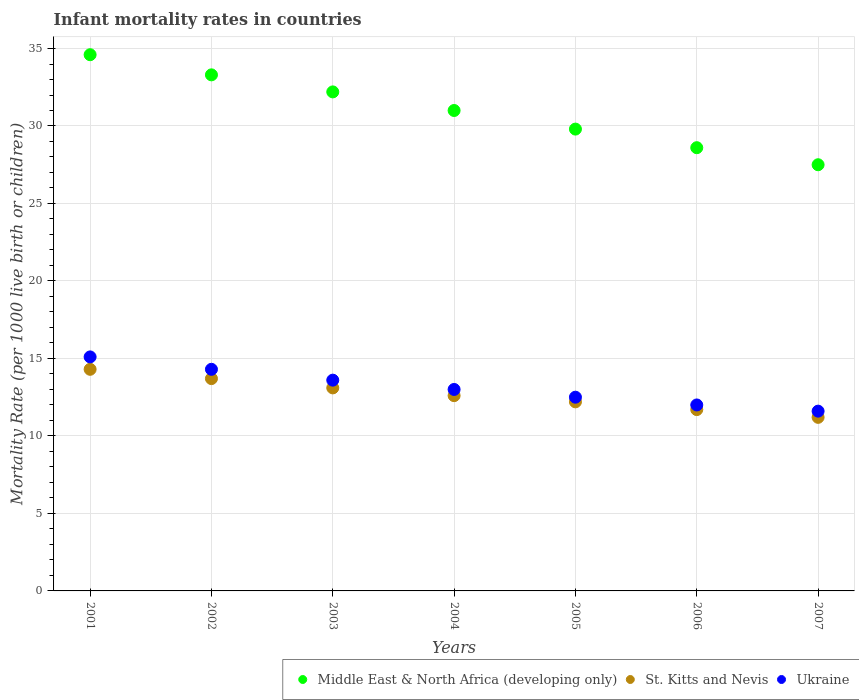Is the number of dotlines equal to the number of legend labels?
Give a very brief answer. Yes. Across all years, what is the maximum infant mortality rate in St. Kitts and Nevis?
Make the answer very short. 14.3. What is the total infant mortality rate in Middle East & North Africa (developing only) in the graph?
Offer a very short reply. 217. What is the difference between the infant mortality rate in St. Kitts and Nevis in 2004 and that in 2006?
Provide a short and direct response. 0.9. What is the difference between the infant mortality rate in St. Kitts and Nevis in 2002 and the infant mortality rate in Ukraine in 2003?
Offer a very short reply. 0.1. What is the average infant mortality rate in Ukraine per year?
Provide a short and direct response. 13.16. In the year 2001, what is the difference between the infant mortality rate in Ukraine and infant mortality rate in Middle East & North Africa (developing only)?
Make the answer very short. -19.5. What is the ratio of the infant mortality rate in Ukraine in 2001 to that in 2007?
Provide a succinct answer. 1.3. What is the difference between the highest and the second highest infant mortality rate in Middle East & North Africa (developing only)?
Your answer should be compact. 1.3. What is the difference between the highest and the lowest infant mortality rate in St. Kitts and Nevis?
Keep it short and to the point. 3.1. Is the sum of the infant mortality rate in Ukraine in 2005 and 2007 greater than the maximum infant mortality rate in Middle East & North Africa (developing only) across all years?
Keep it short and to the point. No. Is the infant mortality rate in Middle East & North Africa (developing only) strictly greater than the infant mortality rate in St. Kitts and Nevis over the years?
Offer a terse response. Yes. Is the infant mortality rate in Middle East & North Africa (developing only) strictly less than the infant mortality rate in Ukraine over the years?
Keep it short and to the point. No. How many dotlines are there?
Keep it short and to the point. 3. How many years are there in the graph?
Offer a very short reply. 7. How are the legend labels stacked?
Offer a very short reply. Horizontal. What is the title of the graph?
Your answer should be very brief. Infant mortality rates in countries. Does "Korea (Republic)" appear as one of the legend labels in the graph?
Offer a very short reply. No. What is the label or title of the X-axis?
Your answer should be very brief. Years. What is the label or title of the Y-axis?
Give a very brief answer. Mortality Rate (per 1000 live birth or children). What is the Mortality Rate (per 1000 live birth or children) of Middle East & North Africa (developing only) in 2001?
Offer a very short reply. 34.6. What is the Mortality Rate (per 1000 live birth or children) in Middle East & North Africa (developing only) in 2002?
Ensure brevity in your answer.  33.3. What is the Mortality Rate (per 1000 live birth or children) in St. Kitts and Nevis in 2002?
Your response must be concise. 13.7. What is the Mortality Rate (per 1000 live birth or children) in Middle East & North Africa (developing only) in 2003?
Offer a terse response. 32.2. What is the Mortality Rate (per 1000 live birth or children) of St. Kitts and Nevis in 2003?
Your answer should be compact. 13.1. What is the Mortality Rate (per 1000 live birth or children) in Ukraine in 2003?
Offer a very short reply. 13.6. What is the Mortality Rate (per 1000 live birth or children) of Middle East & North Africa (developing only) in 2005?
Give a very brief answer. 29.8. What is the Mortality Rate (per 1000 live birth or children) in St. Kitts and Nevis in 2005?
Give a very brief answer. 12.2. What is the Mortality Rate (per 1000 live birth or children) in Middle East & North Africa (developing only) in 2006?
Give a very brief answer. 28.6. What is the Mortality Rate (per 1000 live birth or children) in Middle East & North Africa (developing only) in 2007?
Your response must be concise. 27.5. What is the Mortality Rate (per 1000 live birth or children) in St. Kitts and Nevis in 2007?
Offer a terse response. 11.2. What is the Mortality Rate (per 1000 live birth or children) of Ukraine in 2007?
Ensure brevity in your answer.  11.6. Across all years, what is the maximum Mortality Rate (per 1000 live birth or children) of Middle East & North Africa (developing only)?
Make the answer very short. 34.6. Across all years, what is the maximum Mortality Rate (per 1000 live birth or children) of St. Kitts and Nevis?
Your response must be concise. 14.3. Across all years, what is the maximum Mortality Rate (per 1000 live birth or children) in Ukraine?
Give a very brief answer. 15.1. Across all years, what is the minimum Mortality Rate (per 1000 live birth or children) in Middle East & North Africa (developing only)?
Provide a succinct answer. 27.5. Across all years, what is the minimum Mortality Rate (per 1000 live birth or children) of St. Kitts and Nevis?
Offer a very short reply. 11.2. Across all years, what is the minimum Mortality Rate (per 1000 live birth or children) of Ukraine?
Ensure brevity in your answer.  11.6. What is the total Mortality Rate (per 1000 live birth or children) in Middle East & North Africa (developing only) in the graph?
Offer a very short reply. 217. What is the total Mortality Rate (per 1000 live birth or children) in St. Kitts and Nevis in the graph?
Offer a very short reply. 88.8. What is the total Mortality Rate (per 1000 live birth or children) of Ukraine in the graph?
Keep it short and to the point. 92.1. What is the difference between the Mortality Rate (per 1000 live birth or children) in Middle East & North Africa (developing only) in 2001 and that in 2003?
Your answer should be compact. 2.4. What is the difference between the Mortality Rate (per 1000 live birth or children) of St. Kitts and Nevis in 2001 and that in 2003?
Keep it short and to the point. 1.2. What is the difference between the Mortality Rate (per 1000 live birth or children) of St. Kitts and Nevis in 2001 and that in 2005?
Offer a terse response. 2.1. What is the difference between the Mortality Rate (per 1000 live birth or children) in Ukraine in 2001 and that in 2005?
Your answer should be compact. 2.6. What is the difference between the Mortality Rate (per 1000 live birth or children) in Middle East & North Africa (developing only) in 2001 and that in 2006?
Give a very brief answer. 6. What is the difference between the Mortality Rate (per 1000 live birth or children) in Ukraine in 2001 and that in 2006?
Make the answer very short. 3.1. What is the difference between the Mortality Rate (per 1000 live birth or children) of St. Kitts and Nevis in 2001 and that in 2007?
Offer a terse response. 3.1. What is the difference between the Mortality Rate (per 1000 live birth or children) of Middle East & North Africa (developing only) in 2002 and that in 2003?
Your response must be concise. 1.1. What is the difference between the Mortality Rate (per 1000 live birth or children) of St. Kitts and Nevis in 2002 and that in 2004?
Your response must be concise. 1.1. What is the difference between the Mortality Rate (per 1000 live birth or children) of Ukraine in 2002 and that in 2004?
Offer a very short reply. 1.3. What is the difference between the Mortality Rate (per 1000 live birth or children) of St. Kitts and Nevis in 2002 and that in 2005?
Provide a short and direct response. 1.5. What is the difference between the Mortality Rate (per 1000 live birth or children) of Ukraine in 2002 and that in 2005?
Your answer should be very brief. 1.8. What is the difference between the Mortality Rate (per 1000 live birth or children) of St. Kitts and Nevis in 2002 and that in 2006?
Ensure brevity in your answer.  2. What is the difference between the Mortality Rate (per 1000 live birth or children) of Ukraine in 2002 and that in 2007?
Make the answer very short. 2.7. What is the difference between the Mortality Rate (per 1000 live birth or children) of Middle East & North Africa (developing only) in 2003 and that in 2004?
Give a very brief answer. 1.2. What is the difference between the Mortality Rate (per 1000 live birth or children) of St. Kitts and Nevis in 2003 and that in 2004?
Offer a terse response. 0.5. What is the difference between the Mortality Rate (per 1000 live birth or children) in Middle East & North Africa (developing only) in 2003 and that in 2006?
Give a very brief answer. 3.6. What is the difference between the Mortality Rate (per 1000 live birth or children) in St. Kitts and Nevis in 2003 and that in 2006?
Your answer should be compact. 1.4. What is the difference between the Mortality Rate (per 1000 live birth or children) of Middle East & North Africa (developing only) in 2003 and that in 2007?
Provide a succinct answer. 4.7. What is the difference between the Mortality Rate (per 1000 live birth or children) of St. Kitts and Nevis in 2003 and that in 2007?
Your answer should be compact. 1.9. What is the difference between the Mortality Rate (per 1000 live birth or children) in Middle East & North Africa (developing only) in 2004 and that in 2006?
Keep it short and to the point. 2.4. What is the difference between the Mortality Rate (per 1000 live birth or children) in Ukraine in 2004 and that in 2006?
Offer a very short reply. 1. What is the difference between the Mortality Rate (per 1000 live birth or children) in Middle East & North Africa (developing only) in 2004 and that in 2007?
Offer a terse response. 3.5. What is the difference between the Mortality Rate (per 1000 live birth or children) of Ukraine in 2004 and that in 2007?
Provide a short and direct response. 1.4. What is the difference between the Mortality Rate (per 1000 live birth or children) of Middle East & North Africa (developing only) in 2005 and that in 2006?
Give a very brief answer. 1.2. What is the difference between the Mortality Rate (per 1000 live birth or children) of St. Kitts and Nevis in 2005 and that in 2006?
Offer a terse response. 0.5. What is the difference between the Mortality Rate (per 1000 live birth or children) in Ukraine in 2005 and that in 2006?
Offer a terse response. 0.5. What is the difference between the Mortality Rate (per 1000 live birth or children) of Middle East & North Africa (developing only) in 2005 and that in 2007?
Offer a very short reply. 2.3. What is the difference between the Mortality Rate (per 1000 live birth or children) in Ukraine in 2006 and that in 2007?
Your answer should be compact. 0.4. What is the difference between the Mortality Rate (per 1000 live birth or children) in Middle East & North Africa (developing only) in 2001 and the Mortality Rate (per 1000 live birth or children) in St. Kitts and Nevis in 2002?
Give a very brief answer. 20.9. What is the difference between the Mortality Rate (per 1000 live birth or children) of Middle East & North Africa (developing only) in 2001 and the Mortality Rate (per 1000 live birth or children) of Ukraine in 2002?
Ensure brevity in your answer.  20.3. What is the difference between the Mortality Rate (per 1000 live birth or children) in St. Kitts and Nevis in 2001 and the Mortality Rate (per 1000 live birth or children) in Ukraine in 2002?
Offer a very short reply. 0. What is the difference between the Mortality Rate (per 1000 live birth or children) of Middle East & North Africa (developing only) in 2001 and the Mortality Rate (per 1000 live birth or children) of Ukraine in 2003?
Provide a short and direct response. 21. What is the difference between the Mortality Rate (per 1000 live birth or children) in Middle East & North Africa (developing only) in 2001 and the Mortality Rate (per 1000 live birth or children) in St. Kitts and Nevis in 2004?
Give a very brief answer. 22. What is the difference between the Mortality Rate (per 1000 live birth or children) in Middle East & North Africa (developing only) in 2001 and the Mortality Rate (per 1000 live birth or children) in Ukraine in 2004?
Your response must be concise. 21.6. What is the difference between the Mortality Rate (per 1000 live birth or children) of St. Kitts and Nevis in 2001 and the Mortality Rate (per 1000 live birth or children) of Ukraine in 2004?
Provide a succinct answer. 1.3. What is the difference between the Mortality Rate (per 1000 live birth or children) of Middle East & North Africa (developing only) in 2001 and the Mortality Rate (per 1000 live birth or children) of St. Kitts and Nevis in 2005?
Give a very brief answer. 22.4. What is the difference between the Mortality Rate (per 1000 live birth or children) in Middle East & North Africa (developing only) in 2001 and the Mortality Rate (per 1000 live birth or children) in Ukraine in 2005?
Offer a very short reply. 22.1. What is the difference between the Mortality Rate (per 1000 live birth or children) of St. Kitts and Nevis in 2001 and the Mortality Rate (per 1000 live birth or children) of Ukraine in 2005?
Ensure brevity in your answer.  1.8. What is the difference between the Mortality Rate (per 1000 live birth or children) of Middle East & North Africa (developing only) in 2001 and the Mortality Rate (per 1000 live birth or children) of St. Kitts and Nevis in 2006?
Provide a succinct answer. 22.9. What is the difference between the Mortality Rate (per 1000 live birth or children) in Middle East & North Africa (developing only) in 2001 and the Mortality Rate (per 1000 live birth or children) in Ukraine in 2006?
Your answer should be very brief. 22.6. What is the difference between the Mortality Rate (per 1000 live birth or children) in St. Kitts and Nevis in 2001 and the Mortality Rate (per 1000 live birth or children) in Ukraine in 2006?
Ensure brevity in your answer.  2.3. What is the difference between the Mortality Rate (per 1000 live birth or children) of Middle East & North Africa (developing only) in 2001 and the Mortality Rate (per 1000 live birth or children) of St. Kitts and Nevis in 2007?
Your answer should be very brief. 23.4. What is the difference between the Mortality Rate (per 1000 live birth or children) of St. Kitts and Nevis in 2001 and the Mortality Rate (per 1000 live birth or children) of Ukraine in 2007?
Offer a terse response. 2.7. What is the difference between the Mortality Rate (per 1000 live birth or children) of Middle East & North Africa (developing only) in 2002 and the Mortality Rate (per 1000 live birth or children) of St. Kitts and Nevis in 2003?
Offer a very short reply. 20.2. What is the difference between the Mortality Rate (per 1000 live birth or children) in Middle East & North Africa (developing only) in 2002 and the Mortality Rate (per 1000 live birth or children) in Ukraine in 2003?
Your answer should be compact. 19.7. What is the difference between the Mortality Rate (per 1000 live birth or children) in St. Kitts and Nevis in 2002 and the Mortality Rate (per 1000 live birth or children) in Ukraine in 2003?
Provide a succinct answer. 0.1. What is the difference between the Mortality Rate (per 1000 live birth or children) of Middle East & North Africa (developing only) in 2002 and the Mortality Rate (per 1000 live birth or children) of St. Kitts and Nevis in 2004?
Your response must be concise. 20.7. What is the difference between the Mortality Rate (per 1000 live birth or children) in Middle East & North Africa (developing only) in 2002 and the Mortality Rate (per 1000 live birth or children) in Ukraine in 2004?
Provide a succinct answer. 20.3. What is the difference between the Mortality Rate (per 1000 live birth or children) of Middle East & North Africa (developing only) in 2002 and the Mortality Rate (per 1000 live birth or children) of St. Kitts and Nevis in 2005?
Offer a terse response. 21.1. What is the difference between the Mortality Rate (per 1000 live birth or children) of Middle East & North Africa (developing only) in 2002 and the Mortality Rate (per 1000 live birth or children) of Ukraine in 2005?
Offer a very short reply. 20.8. What is the difference between the Mortality Rate (per 1000 live birth or children) in Middle East & North Africa (developing only) in 2002 and the Mortality Rate (per 1000 live birth or children) in St. Kitts and Nevis in 2006?
Provide a succinct answer. 21.6. What is the difference between the Mortality Rate (per 1000 live birth or children) in Middle East & North Africa (developing only) in 2002 and the Mortality Rate (per 1000 live birth or children) in Ukraine in 2006?
Offer a very short reply. 21.3. What is the difference between the Mortality Rate (per 1000 live birth or children) in Middle East & North Africa (developing only) in 2002 and the Mortality Rate (per 1000 live birth or children) in St. Kitts and Nevis in 2007?
Give a very brief answer. 22.1. What is the difference between the Mortality Rate (per 1000 live birth or children) of Middle East & North Africa (developing only) in 2002 and the Mortality Rate (per 1000 live birth or children) of Ukraine in 2007?
Provide a succinct answer. 21.7. What is the difference between the Mortality Rate (per 1000 live birth or children) of St. Kitts and Nevis in 2002 and the Mortality Rate (per 1000 live birth or children) of Ukraine in 2007?
Ensure brevity in your answer.  2.1. What is the difference between the Mortality Rate (per 1000 live birth or children) in Middle East & North Africa (developing only) in 2003 and the Mortality Rate (per 1000 live birth or children) in St. Kitts and Nevis in 2004?
Offer a very short reply. 19.6. What is the difference between the Mortality Rate (per 1000 live birth or children) of Middle East & North Africa (developing only) in 2003 and the Mortality Rate (per 1000 live birth or children) of Ukraine in 2004?
Your response must be concise. 19.2. What is the difference between the Mortality Rate (per 1000 live birth or children) of Middle East & North Africa (developing only) in 2003 and the Mortality Rate (per 1000 live birth or children) of St. Kitts and Nevis in 2005?
Provide a short and direct response. 20. What is the difference between the Mortality Rate (per 1000 live birth or children) of Middle East & North Africa (developing only) in 2003 and the Mortality Rate (per 1000 live birth or children) of Ukraine in 2005?
Ensure brevity in your answer.  19.7. What is the difference between the Mortality Rate (per 1000 live birth or children) of St. Kitts and Nevis in 2003 and the Mortality Rate (per 1000 live birth or children) of Ukraine in 2005?
Make the answer very short. 0.6. What is the difference between the Mortality Rate (per 1000 live birth or children) of Middle East & North Africa (developing only) in 2003 and the Mortality Rate (per 1000 live birth or children) of St. Kitts and Nevis in 2006?
Provide a succinct answer. 20.5. What is the difference between the Mortality Rate (per 1000 live birth or children) of Middle East & North Africa (developing only) in 2003 and the Mortality Rate (per 1000 live birth or children) of Ukraine in 2006?
Ensure brevity in your answer.  20.2. What is the difference between the Mortality Rate (per 1000 live birth or children) of Middle East & North Africa (developing only) in 2003 and the Mortality Rate (per 1000 live birth or children) of Ukraine in 2007?
Offer a very short reply. 20.6. What is the difference between the Mortality Rate (per 1000 live birth or children) of St. Kitts and Nevis in 2003 and the Mortality Rate (per 1000 live birth or children) of Ukraine in 2007?
Your answer should be very brief. 1.5. What is the difference between the Mortality Rate (per 1000 live birth or children) in Middle East & North Africa (developing only) in 2004 and the Mortality Rate (per 1000 live birth or children) in St. Kitts and Nevis in 2005?
Keep it short and to the point. 18.8. What is the difference between the Mortality Rate (per 1000 live birth or children) in Middle East & North Africa (developing only) in 2004 and the Mortality Rate (per 1000 live birth or children) in St. Kitts and Nevis in 2006?
Your answer should be compact. 19.3. What is the difference between the Mortality Rate (per 1000 live birth or children) in Middle East & North Africa (developing only) in 2004 and the Mortality Rate (per 1000 live birth or children) in St. Kitts and Nevis in 2007?
Make the answer very short. 19.8. What is the difference between the Mortality Rate (per 1000 live birth or children) in St. Kitts and Nevis in 2004 and the Mortality Rate (per 1000 live birth or children) in Ukraine in 2007?
Your answer should be compact. 1. What is the difference between the Mortality Rate (per 1000 live birth or children) of St. Kitts and Nevis in 2005 and the Mortality Rate (per 1000 live birth or children) of Ukraine in 2006?
Give a very brief answer. 0.2. What is the difference between the Mortality Rate (per 1000 live birth or children) in Middle East & North Africa (developing only) in 2005 and the Mortality Rate (per 1000 live birth or children) in Ukraine in 2007?
Your answer should be compact. 18.2. What is the difference between the Mortality Rate (per 1000 live birth or children) in Middle East & North Africa (developing only) in 2006 and the Mortality Rate (per 1000 live birth or children) in St. Kitts and Nevis in 2007?
Make the answer very short. 17.4. What is the difference between the Mortality Rate (per 1000 live birth or children) in Middle East & North Africa (developing only) in 2006 and the Mortality Rate (per 1000 live birth or children) in Ukraine in 2007?
Keep it short and to the point. 17. What is the difference between the Mortality Rate (per 1000 live birth or children) of St. Kitts and Nevis in 2006 and the Mortality Rate (per 1000 live birth or children) of Ukraine in 2007?
Provide a succinct answer. 0.1. What is the average Mortality Rate (per 1000 live birth or children) of Middle East & North Africa (developing only) per year?
Provide a short and direct response. 31. What is the average Mortality Rate (per 1000 live birth or children) of St. Kitts and Nevis per year?
Offer a very short reply. 12.69. What is the average Mortality Rate (per 1000 live birth or children) of Ukraine per year?
Keep it short and to the point. 13.16. In the year 2001, what is the difference between the Mortality Rate (per 1000 live birth or children) of Middle East & North Africa (developing only) and Mortality Rate (per 1000 live birth or children) of St. Kitts and Nevis?
Your response must be concise. 20.3. In the year 2001, what is the difference between the Mortality Rate (per 1000 live birth or children) in Middle East & North Africa (developing only) and Mortality Rate (per 1000 live birth or children) in Ukraine?
Provide a short and direct response. 19.5. In the year 2001, what is the difference between the Mortality Rate (per 1000 live birth or children) of St. Kitts and Nevis and Mortality Rate (per 1000 live birth or children) of Ukraine?
Make the answer very short. -0.8. In the year 2002, what is the difference between the Mortality Rate (per 1000 live birth or children) in Middle East & North Africa (developing only) and Mortality Rate (per 1000 live birth or children) in St. Kitts and Nevis?
Offer a very short reply. 19.6. In the year 2003, what is the difference between the Mortality Rate (per 1000 live birth or children) of Middle East & North Africa (developing only) and Mortality Rate (per 1000 live birth or children) of St. Kitts and Nevis?
Your answer should be very brief. 19.1. In the year 2004, what is the difference between the Mortality Rate (per 1000 live birth or children) in Middle East & North Africa (developing only) and Mortality Rate (per 1000 live birth or children) in St. Kitts and Nevis?
Your answer should be compact. 18.4. In the year 2005, what is the difference between the Mortality Rate (per 1000 live birth or children) of Middle East & North Africa (developing only) and Mortality Rate (per 1000 live birth or children) of St. Kitts and Nevis?
Ensure brevity in your answer.  17.6. In the year 2006, what is the difference between the Mortality Rate (per 1000 live birth or children) of St. Kitts and Nevis and Mortality Rate (per 1000 live birth or children) of Ukraine?
Provide a short and direct response. -0.3. In the year 2007, what is the difference between the Mortality Rate (per 1000 live birth or children) in St. Kitts and Nevis and Mortality Rate (per 1000 live birth or children) in Ukraine?
Your answer should be compact. -0.4. What is the ratio of the Mortality Rate (per 1000 live birth or children) in Middle East & North Africa (developing only) in 2001 to that in 2002?
Provide a succinct answer. 1.04. What is the ratio of the Mortality Rate (per 1000 live birth or children) in St. Kitts and Nevis in 2001 to that in 2002?
Your answer should be compact. 1.04. What is the ratio of the Mortality Rate (per 1000 live birth or children) in Ukraine in 2001 to that in 2002?
Provide a short and direct response. 1.06. What is the ratio of the Mortality Rate (per 1000 live birth or children) of Middle East & North Africa (developing only) in 2001 to that in 2003?
Your answer should be compact. 1.07. What is the ratio of the Mortality Rate (per 1000 live birth or children) in St. Kitts and Nevis in 2001 to that in 2003?
Your answer should be very brief. 1.09. What is the ratio of the Mortality Rate (per 1000 live birth or children) in Ukraine in 2001 to that in 2003?
Your answer should be very brief. 1.11. What is the ratio of the Mortality Rate (per 1000 live birth or children) of Middle East & North Africa (developing only) in 2001 to that in 2004?
Ensure brevity in your answer.  1.12. What is the ratio of the Mortality Rate (per 1000 live birth or children) in St. Kitts and Nevis in 2001 to that in 2004?
Give a very brief answer. 1.13. What is the ratio of the Mortality Rate (per 1000 live birth or children) in Ukraine in 2001 to that in 2004?
Ensure brevity in your answer.  1.16. What is the ratio of the Mortality Rate (per 1000 live birth or children) in Middle East & North Africa (developing only) in 2001 to that in 2005?
Your answer should be very brief. 1.16. What is the ratio of the Mortality Rate (per 1000 live birth or children) of St. Kitts and Nevis in 2001 to that in 2005?
Your answer should be compact. 1.17. What is the ratio of the Mortality Rate (per 1000 live birth or children) of Ukraine in 2001 to that in 2005?
Make the answer very short. 1.21. What is the ratio of the Mortality Rate (per 1000 live birth or children) in Middle East & North Africa (developing only) in 2001 to that in 2006?
Your answer should be very brief. 1.21. What is the ratio of the Mortality Rate (per 1000 live birth or children) of St. Kitts and Nevis in 2001 to that in 2006?
Your response must be concise. 1.22. What is the ratio of the Mortality Rate (per 1000 live birth or children) of Ukraine in 2001 to that in 2006?
Offer a terse response. 1.26. What is the ratio of the Mortality Rate (per 1000 live birth or children) in Middle East & North Africa (developing only) in 2001 to that in 2007?
Ensure brevity in your answer.  1.26. What is the ratio of the Mortality Rate (per 1000 live birth or children) of St. Kitts and Nevis in 2001 to that in 2007?
Give a very brief answer. 1.28. What is the ratio of the Mortality Rate (per 1000 live birth or children) of Ukraine in 2001 to that in 2007?
Your response must be concise. 1.3. What is the ratio of the Mortality Rate (per 1000 live birth or children) in Middle East & North Africa (developing only) in 2002 to that in 2003?
Your answer should be very brief. 1.03. What is the ratio of the Mortality Rate (per 1000 live birth or children) of St. Kitts and Nevis in 2002 to that in 2003?
Provide a succinct answer. 1.05. What is the ratio of the Mortality Rate (per 1000 live birth or children) of Ukraine in 2002 to that in 2003?
Offer a terse response. 1.05. What is the ratio of the Mortality Rate (per 1000 live birth or children) of Middle East & North Africa (developing only) in 2002 to that in 2004?
Your answer should be very brief. 1.07. What is the ratio of the Mortality Rate (per 1000 live birth or children) of St. Kitts and Nevis in 2002 to that in 2004?
Give a very brief answer. 1.09. What is the ratio of the Mortality Rate (per 1000 live birth or children) in Ukraine in 2002 to that in 2004?
Provide a short and direct response. 1.1. What is the ratio of the Mortality Rate (per 1000 live birth or children) of Middle East & North Africa (developing only) in 2002 to that in 2005?
Your response must be concise. 1.12. What is the ratio of the Mortality Rate (per 1000 live birth or children) in St. Kitts and Nevis in 2002 to that in 2005?
Your response must be concise. 1.12. What is the ratio of the Mortality Rate (per 1000 live birth or children) in Ukraine in 2002 to that in 2005?
Make the answer very short. 1.14. What is the ratio of the Mortality Rate (per 1000 live birth or children) in Middle East & North Africa (developing only) in 2002 to that in 2006?
Keep it short and to the point. 1.16. What is the ratio of the Mortality Rate (per 1000 live birth or children) of St. Kitts and Nevis in 2002 to that in 2006?
Offer a terse response. 1.17. What is the ratio of the Mortality Rate (per 1000 live birth or children) in Ukraine in 2002 to that in 2006?
Offer a very short reply. 1.19. What is the ratio of the Mortality Rate (per 1000 live birth or children) of Middle East & North Africa (developing only) in 2002 to that in 2007?
Your answer should be very brief. 1.21. What is the ratio of the Mortality Rate (per 1000 live birth or children) of St. Kitts and Nevis in 2002 to that in 2007?
Offer a very short reply. 1.22. What is the ratio of the Mortality Rate (per 1000 live birth or children) in Ukraine in 2002 to that in 2007?
Offer a very short reply. 1.23. What is the ratio of the Mortality Rate (per 1000 live birth or children) of Middle East & North Africa (developing only) in 2003 to that in 2004?
Your answer should be very brief. 1.04. What is the ratio of the Mortality Rate (per 1000 live birth or children) in St. Kitts and Nevis in 2003 to that in 2004?
Provide a succinct answer. 1.04. What is the ratio of the Mortality Rate (per 1000 live birth or children) in Ukraine in 2003 to that in 2004?
Give a very brief answer. 1.05. What is the ratio of the Mortality Rate (per 1000 live birth or children) in Middle East & North Africa (developing only) in 2003 to that in 2005?
Offer a terse response. 1.08. What is the ratio of the Mortality Rate (per 1000 live birth or children) of St. Kitts and Nevis in 2003 to that in 2005?
Give a very brief answer. 1.07. What is the ratio of the Mortality Rate (per 1000 live birth or children) of Ukraine in 2003 to that in 2005?
Ensure brevity in your answer.  1.09. What is the ratio of the Mortality Rate (per 1000 live birth or children) in Middle East & North Africa (developing only) in 2003 to that in 2006?
Your response must be concise. 1.13. What is the ratio of the Mortality Rate (per 1000 live birth or children) of St. Kitts and Nevis in 2003 to that in 2006?
Ensure brevity in your answer.  1.12. What is the ratio of the Mortality Rate (per 1000 live birth or children) of Ukraine in 2003 to that in 2006?
Make the answer very short. 1.13. What is the ratio of the Mortality Rate (per 1000 live birth or children) of Middle East & North Africa (developing only) in 2003 to that in 2007?
Provide a succinct answer. 1.17. What is the ratio of the Mortality Rate (per 1000 live birth or children) in St. Kitts and Nevis in 2003 to that in 2007?
Offer a terse response. 1.17. What is the ratio of the Mortality Rate (per 1000 live birth or children) in Ukraine in 2003 to that in 2007?
Keep it short and to the point. 1.17. What is the ratio of the Mortality Rate (per 1000 live birth or children) in Middle East & North Africa (developing only) in 2004 to that in 2005?
Give a very brief answer. 1.04. What is the ratio of the Mortality Rate (per 1000 live birth or children) in St. Kitts and Nevis in 2004 to that in 2005?
Ensure brevity in your answer.  1.03. What is the ratio of the Mortality Rate (per 1000 live birth or children) in Ukraine in 2004 to that in 2005?
Make the answer very short. 1.04. What is the ratio of the Mortality Rate (per 1000 live birth or children) in Middle East & North Africa (developing only) in 2004 to that in 2006?
Offer a terse response. 1.08. What is the ratio of the Mortality Rate (per 1000 live birth or children) of St. Kitts and Nevis in 2004 to that in 2006?
Give a very brief answer. 1.08. What is the ratio of the Mortality Rate (per 1000 live birth or children) in Ukraine in 2004 to that in 2006?
Keep it short and to the point. 1.08. What is the ratio of the Mortality Rate (per 1000 live birth or children) of Middle East & North Africa (developing only) in 2004 to that in 2007?
Give a very brief answer. 1.13. What is the ratio of the Mortality Rate (per 1000 live birth or children) of St. Kitts and Nevis in 2004 to that in 2007?
Your answer should be compact. 1.12. What is the ratio of the Mortality Rate (per 1000 live birth or children) in Ukraine in 2004 to that in 2007?
Ensure brevity in your answer.  1.12. What is the ratio of the Mortality Rate (per 1000 live birth or children) in Middle East & North Africa (developing only) in 2005 to that in 2006?
Your response must be concise. 1.04. What is the ratio of the Mortality Rate (per 1000 live birth or children) in St. Kitts and Nevis in 2005 to that in 2006?
Your response must be concise. 1.04. What is the ratio of the Mortality Rate (per 1000 live birth or children) of Ukraine in 2005 to that in 2006?
Provide a short and direct response. 1.04. What is the ratio of the Mortality Rate (per 1000 live birth or children) of Middle East & North Africa (developing only) in 2005 to that in 2007?
Give a very brief answer. 1.08. What is the ratio of the Mortality Rate (per 1000 live birth or children) in St. Kitts and Nevis in 2005 to that in 2007?
Offer a very short reply. 1.09. What is the ratio of the Mortality Rate (per 1000 live birth or children) in Ukraine in 2005 to that in 2007?
Your response must be concise. 1.08. What is the ratio of the Mortality Rate (per 1000 live birth or children) of St. Kitts and Nevis in 2006 to that in 2007?
Provide a short and direct response. 1.04. What is the ratio of the Mortality Rate (per 1000 live birth or children) of Ukraine in 2006 to that in 2007?
Make the answer very short. 1.03. What is the difference between the highest and the second highest Mortality Rate (per 1000 live birth or children) in St. Kitts and Nevis?
Keep it short and to the point. 0.6. What is the difference between the highest and the lowest Mortality Rate (per 1000 live birth or children) in Ukraine?
Your response must be concise. 3.5. 